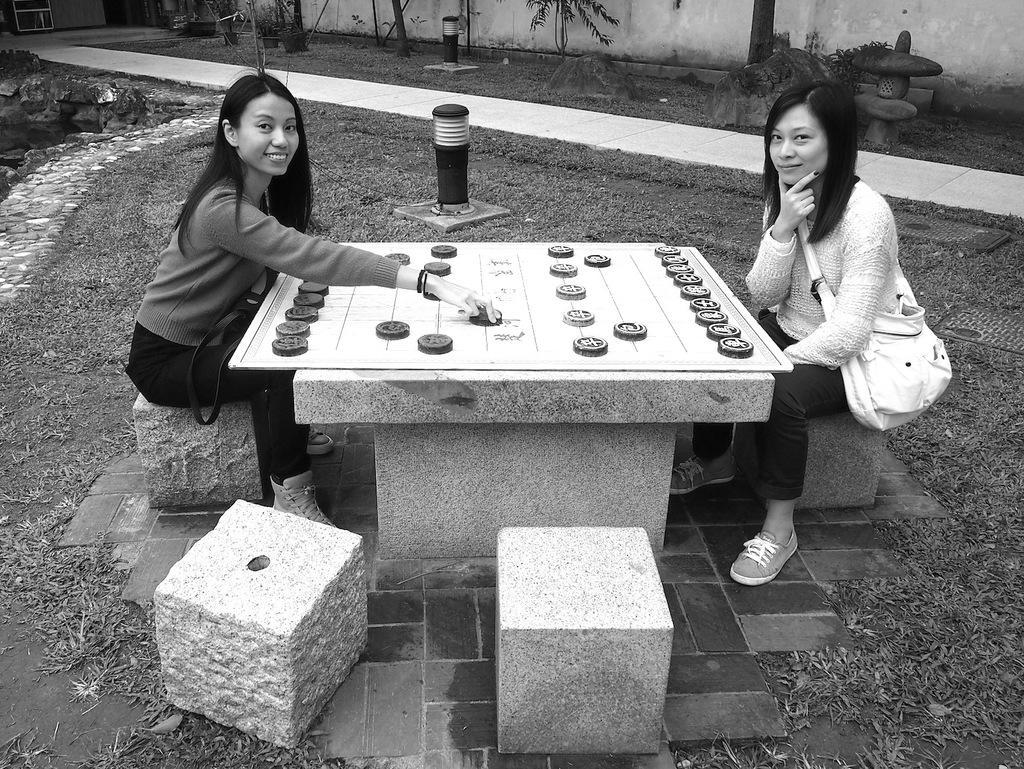Please provide a concise description of this image. Two women's sitting on a rock and playing a game which is in front of them. 